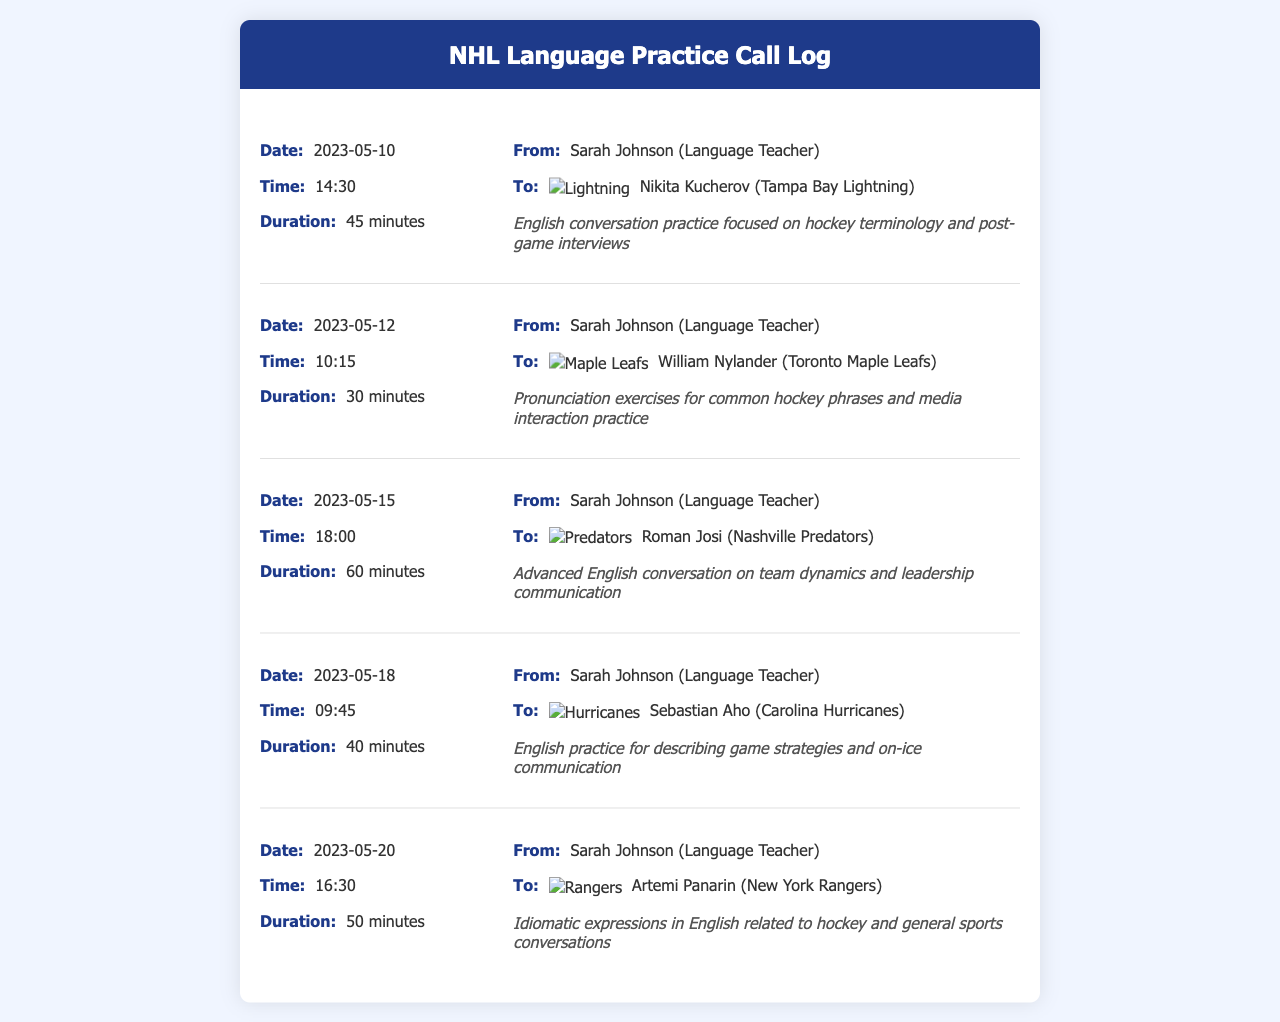What was the duration of the call with Nikita Kucherov? The duration of the call on 2023-05-10 with Nikita Kucherov was specified as 45 minutes.
Answer: 45 minutes Who was the language teacher involved in the calls? The document indicates that Sarah Johnson was the language teacher in all calls listed.
Answer: Sarah Johnson What date did the call with Sebastian Aho take place? The specific date for the call with Sebastian Aho is provided as 2023-05-18 in the records.
Answer: 2023-05-18 Which NHL team does Roman Josi play for? The document shows that Roman Josi is associated with the Nashville Predators as indicated by the team logo in the call log.
Answer: Nashville Predators How many minutes was the longest call? By reviewing the call durations, the longest call noted was with Roman Josi, which lasted 60 minutes.
Answer: 60 minutes On what date was the call with William Nylander made? The call with William Nylander occurred on the date mentioned as 2023-05-12.
Answer: 2023-05-12 What was the main focus of the call with Artemi Panarin? The focus of the call with Artemi Panarin was idiomatic expressions in English related to hockey and sports conversations.
Answer: Idiomatic expressions How many international calls were logged in total? There are a total of five international calls recorded in the document for different NHL players.
Answer: Five What time was the call with Roman Josi? The call with Roman Josi took place at 18:00, as indicated in the log.
Answer: 18:00 